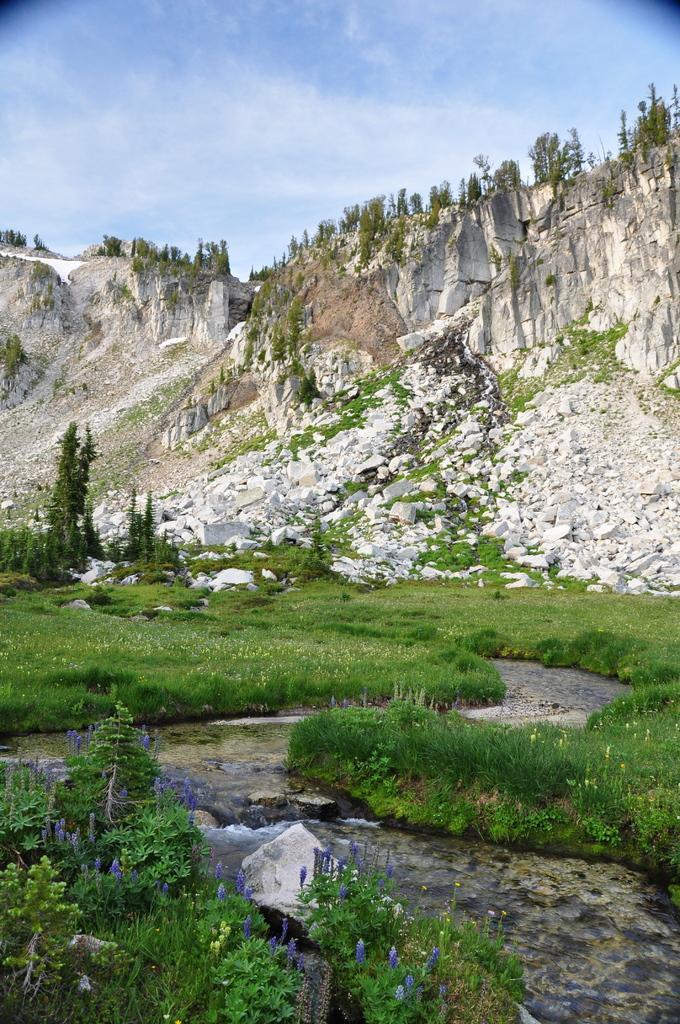Can you describe this image briefly? These are the rock hills. I can see small plants with flowers. These are the trees. Here is the water flowing. 